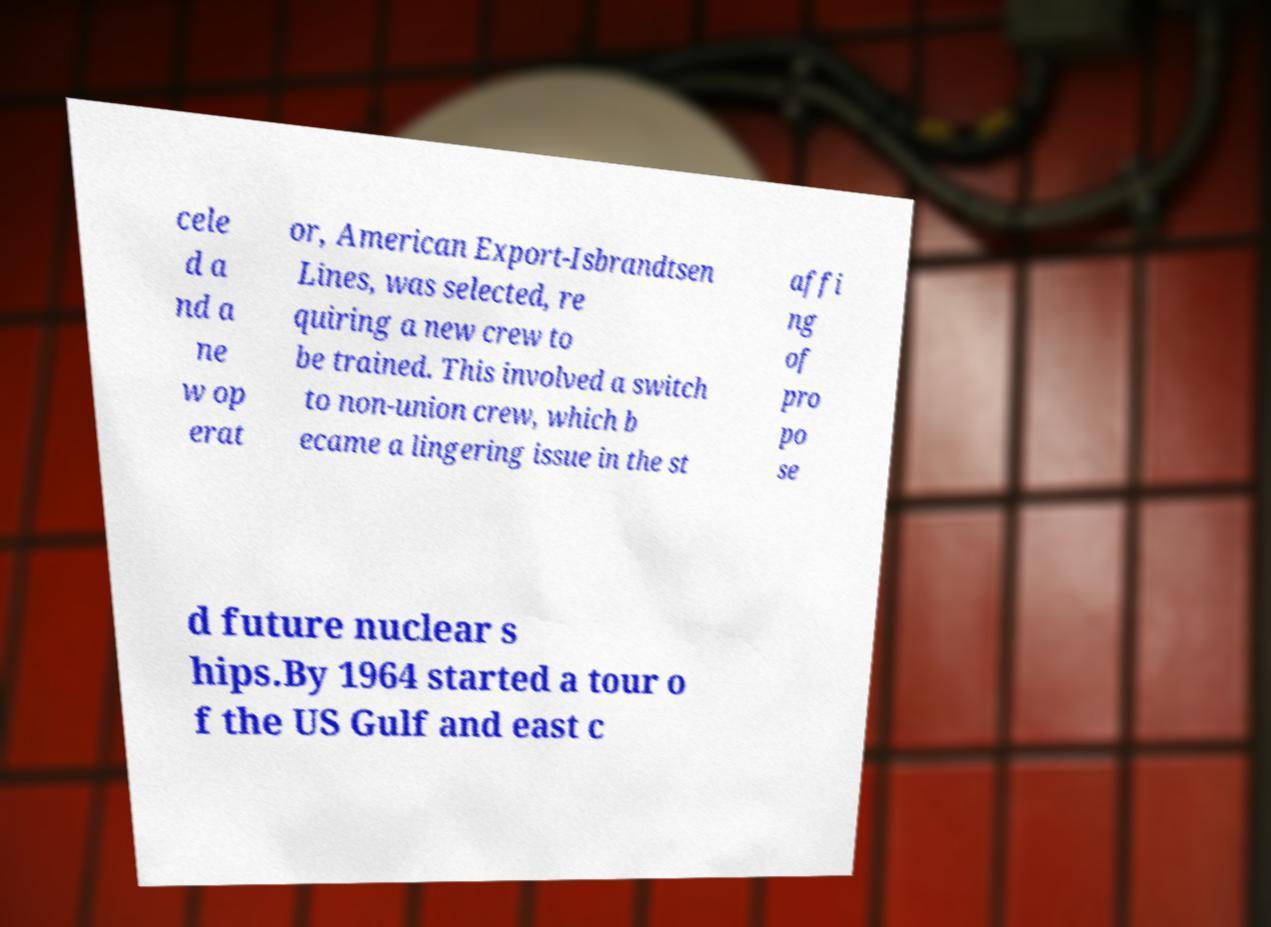There's text embedded in this image that I need extracted. Can you transcribe it verbatim? cele d a nd a ne w op erat or, American Export-Isbrandtsen Lines, was selected, re quiring a new crew to be trained. This involved a switch to non-union crew, which b ecame a lingering issue in the st affi ng of pro po se d future nuclear s hips.By 1964 started a tour o f the US Gulf and east c 